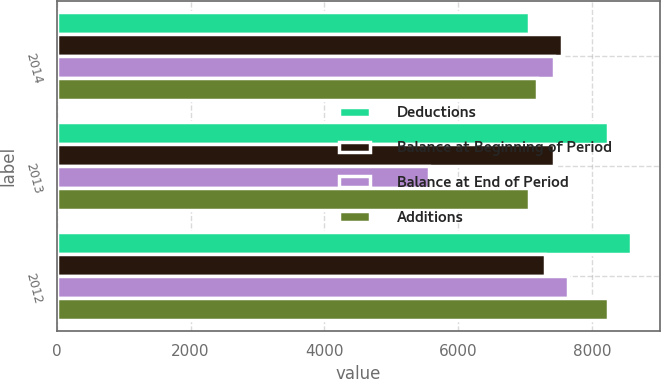<chart> <loc_0><loc_0><loc_500><loc_500><stacked_bar_chart><ecel><fcel>2014<fcel>2013<fcel>2012<nl><fcel>Deductions<fcel>7057<fcel>8240<fcel>8584<nl><fcel>Balance at Beginning of Period<fcel>7551<fcel>7429<fcel>7298<nl><fcel>Balance at End of Period<fcel>7429<fcel>5569<fcel>7642<nl><fcel>Additions<fcel>7179<fcel>7057<fcel>8240<nl></chart> 